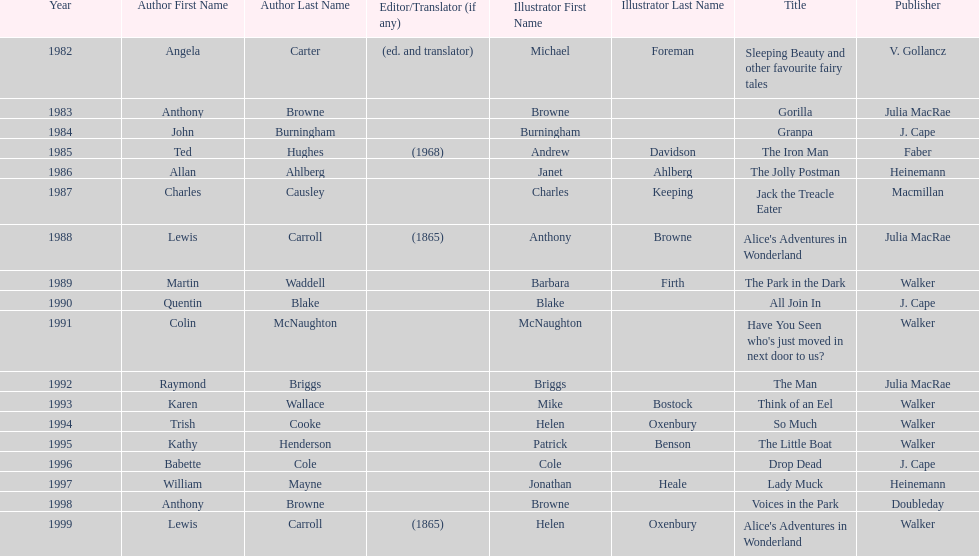How many number of titles are listed for the year 1991? 1. 